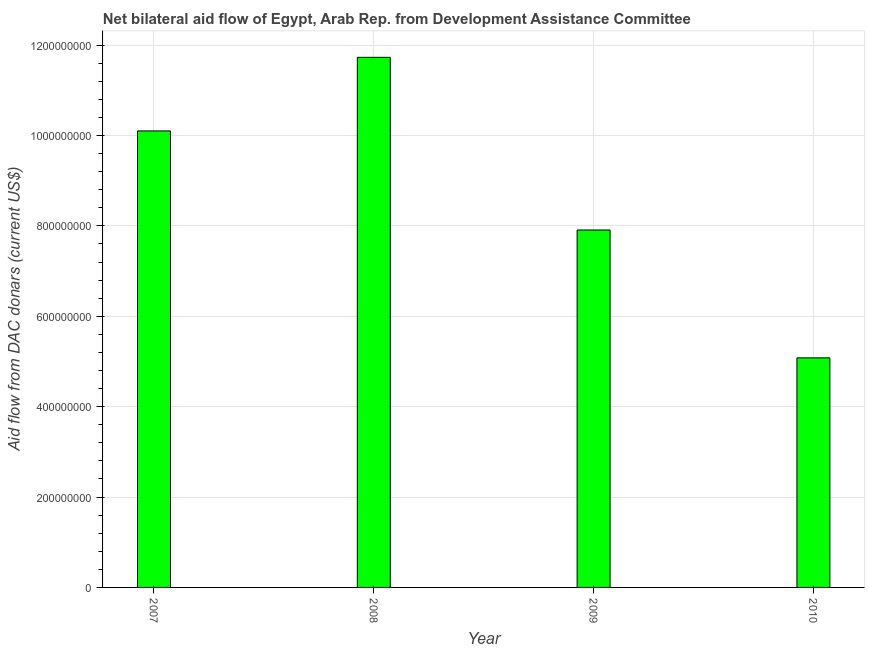Does the graph contain grids?
Ensure brevity in your answer.  Yes. What is the title of the graph?
Ensure brevity in your answer.  Net bilateral aid flow of Egypt, Arab Rep. from Development Assistance Committee. What is the label or title of the X-axis?
Offer a terse response. Year. What is the label or title of the Y-axis?
Ensure brevity in your answer.  Aid flow from DAC donars (current US$). What is the net bilateral aid flows from dac donors in 2010?
Keep it short and to the point. 5.08e+08. Across all years, what is the maximum net bilateral aid flows from dac donors?
Offer a terse response. 1.17e+09. Across all years, what is the minimum net bilateral aid flows from dac donors?
Make the answer very short. 5.08e+08. In which year was the net bilateral aid flows from dac donors maximum?
Your response must be concise. 2008. What is the sum of the net bilateral aid flows from dac donors?
Your answer should be compact. 3.48e+09. What is the difference between the net bilateral aid flows from dac donors in 2007 and 2009?
Provide a succinct answer. 2.19e+08. What is the average net bilateral aid flows from dac donors per year?
Provide a succinct answer. 8.70e+08. What is the median net bilateral aid flows from dac donors?
Your response must be concise. 9.00e+08. Do a majority of the years between 2007 and 2010 (inclusive) have net bilateral aid flows from dac donors greater than 400000000 US$?
Make the answer very short. Yes. What is the ratio of the net bilateral aid flows from dac donors in 2007 to that in 2010?
Offer a terse response. 1.99. Is the net bilateral aid flows from dac donors in 2007 less than that in 2009?
Your answer should be compact. No. Is the difference between the net bilateral aid flows from dac donors in 2008 and 2010 greater than the difference between any two years?
Give a very brief answer. Yes. What is the difference between the highest and the second highest net bilateral aid flows from dac donors?
Make the answer very short. 1.63e+08. Is the sum of the net bilateral aid flows from dac donors in 2008 and 2010 greater than the maximum net bilateral aid flows from dac donors across all years?
Make the answer very short. Yes. What is the difference between the highest and the lowest net bilateral aid flows from dac donors?
Ensure brevity in your answer.  6.65e+08. How many bars are there?
Give a very brief answer. 4. Are all the bars in the graph horizontal?
Ensure brevity in your answer.  No. What is the difference between two consecutive major ticks on the Y-axis?
Provide a short and direct response. 2.00e+08. Are the values on the major ticks of Y-axis written in scientific E-notation?
Your response must be concise. No. What is the Aid flow from DAC donars (current US$) of 2007?
Offer a very short reply. 1.01e+09. What is the Aid flow from DAC donars (current US$) in 2008?
Make the answer very short. 1.17e+09. What is the Aid flow from DAC donars (current US$) of 2009?
Provide a succinct answer. 7.91e+08. What is the Aid flow from DAC donars (current US$) in 2010?
Keep it short and to the point. 5.08e+08. What is the difference between the Aid flow from DAC donars (current US$) in 2007 and 2008?
Provide a short and direct response. -1.63e+08. What is the difference between the Aid flow from DAC donars (current US$) in 2007 and 2009?
Provide a short and direct response. 2.19e+08. What is the difference between the Aid flow from DAC donars (current US$) in 2007 and 2010?
Your response must be concise. 5.02e+08. What is the difference between the Aid flow from DAC donars (current US$) in 2008 and 2009?
Ensure brevity in your answer.  3.82e+08. What is the difference between the Aid flow from DAC donars (current US$) in 2008 and 2010?
Keep it short and to the point. 6.65e+08. What is the difference between the Aid flow from DAC donars (current US$) in 2009 and 2010?
Provide a short and direct response. 2.83e+08. What is the ratio of the Aid flow from DAC donars (current US$) in 2007 to that in 2008?
Ensure brevity in your answer.  0.86. What is the ratio of the Aid flow from DAC donars (current US$) in 2007 to that in 2009?
Your answer should be compact. 1.28. What is the ratio of the Aid flow from DAC donars (current US$) in 2007 to that in 2010?
Make the answer very short. 1.99. What is the ratio of the Aid flow from DAC donars (current US$) in 2008 to that in 2009?
Give a very brief answer. 1.48. What is the ratio of the Aid flow from DAC donars (current US$) in 2008 to that in 2010?
Offer a terse response. 2.31. What is the ratio of the Aid flow from DAC donars (current US$) in 2009 to that in 2010?
Provide a short and direct response. 1.56. 